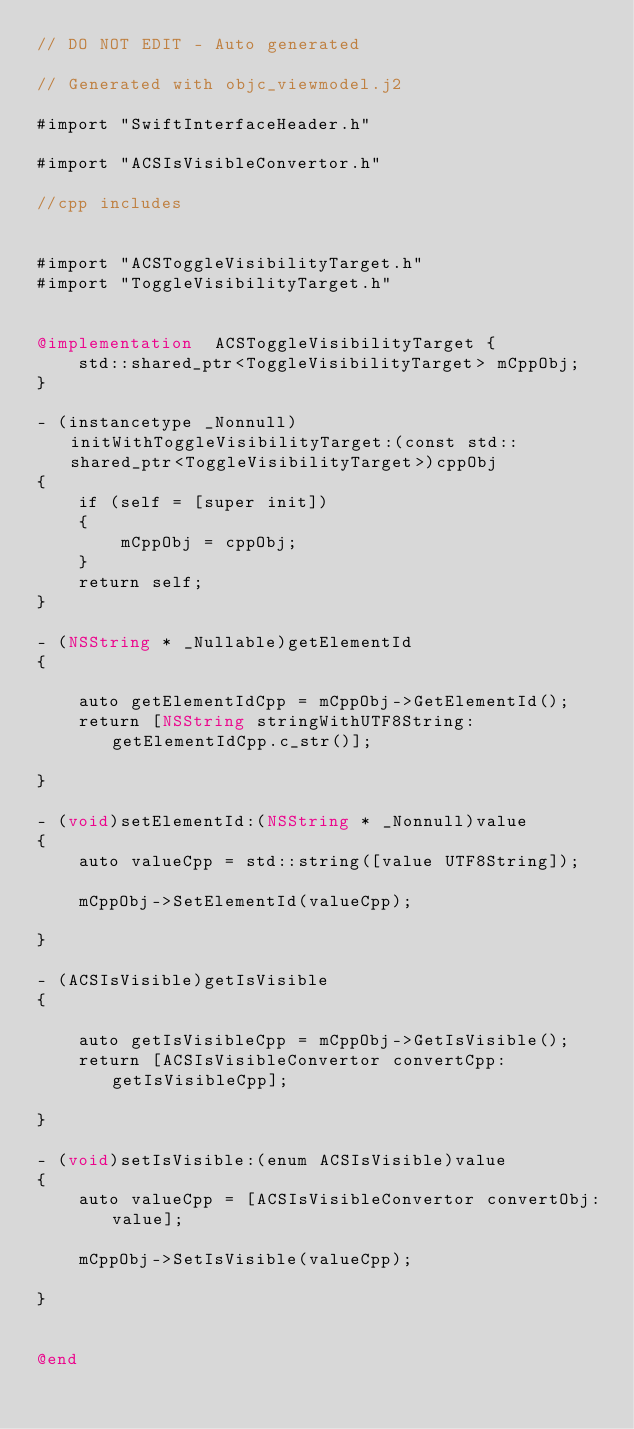Convert code to text. <code><loc_0><loc_0><loc_500><loc_500><_ObjectiveC_>// DO NOT EDIT - Auto generated

// Generated with objc_viewmodel.j2

#import "SwiftInterfaceHeader.h"

#import "ACSIsVisibleConvertor.h"

//cpp includes


#import "ACSToggleVisibilityTarget.h"
#import "ToggleVisibilityTarget.h"


@implementation  ACSToggleVisibilityTarget {
    std::shared_ptr<ToggleVisibilityTarget> mCppObj;
}

- (instancetype _Nonnull)initWithToggleVisibilityTarget:(const std::shared_ptr<ToggleVisibilityTarget>)cppObj
{
    if (self = [super init])
    {
        mCppObj = cppObj;
    }
    return self;
}

- (NSString * _Nullable)getElementId
{
 
    auto getElementIdCpp = mCppObj->GetElementId();
    return [NSString stringWithUTF8String:getElementIdCpp.c_str()];

}

- (void)setElementId:(NSString * _Nonnull)value
{
    auto valueCpp = std::string([value UTF8String]);
 
    mCppObj->SetElementId(valueCpp);
    
}

- (ACSIsVisible)getIsVisible
{
 
    auto getIsVisibleCpp = mCppObj->GetIsVisible();
    return [ACSIsVisibleConvertor convertCpp:getIsVisibleCpp];

}

- (void)setIsVisible:(enum ACSIsVisible)value
{
    auto valueCpp = [ACSIsVisibleConvertor convertObj:value];
 
    mCppObj->SetIsVisible(valueCpp);
    
}


@end
</code> 